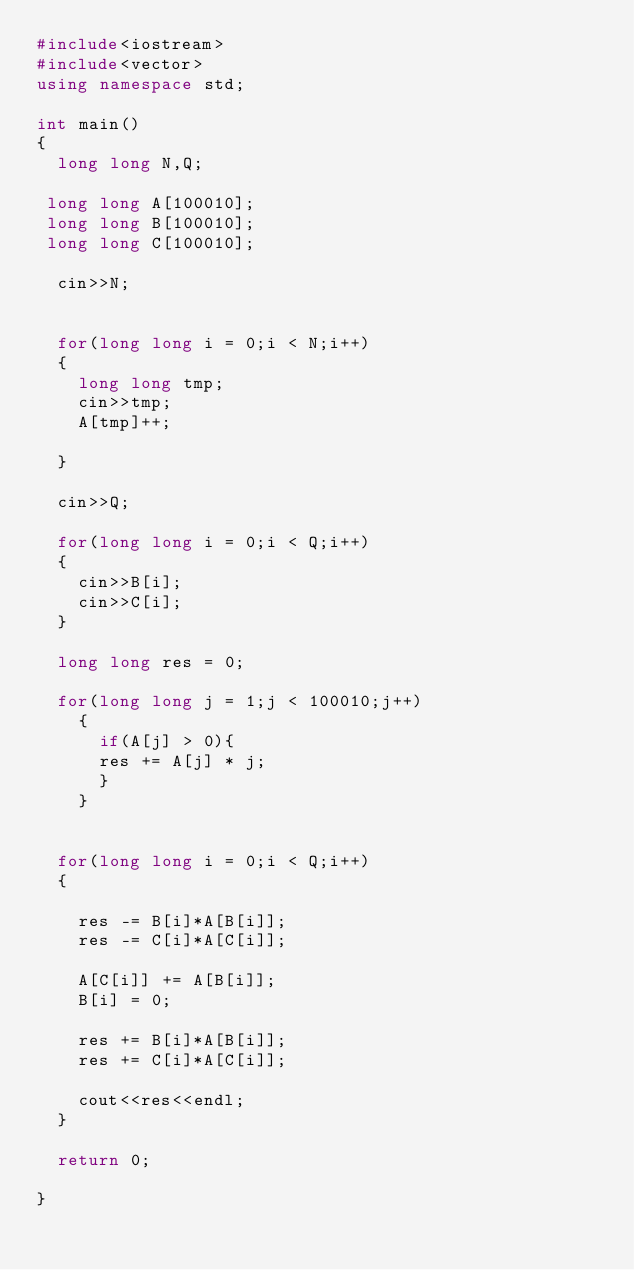<code> <loc_0><loc_0><loc_500><loc_500><_C++_>#include<iostream>
#include<vector>
using namespace std;
 
int main()
{
  long long N,Q;
  
 long long A[100010];
 long long B[100010];
 long long C[100010];
  
  cin>>N;
  
  
  for(long long i = 0;i < N;i++)
  {
    long long tmp;
    cin>>tmp;
    A[tmp]++;

  }
  
  cin>>Q;
  
  for(long long i = 0;i < Q;i++)
  {
    cin>>B[i];
    cin>>C[i];
  }
  
  long long res = 0;
  
  for(long long j = 1;j < 100010;j++)
    {
      if(A[j] > 0){
      res += A[j] * j; 
      }
    }
  
  
  for(long long i = 0;i < Q;i++)
  {
    
    res -= B[i]*A[B[i]];
    res -= C[i]*A[C[i]];
    
    A[C[i]] += A[B[i]];
    B[i] = 0;
    
    res += B[i]*A[B[i]];
    res += C[i]*A[C[i]];
    
    cout<<res<<endl;
  }
  
  return 0;
 
}</code> 